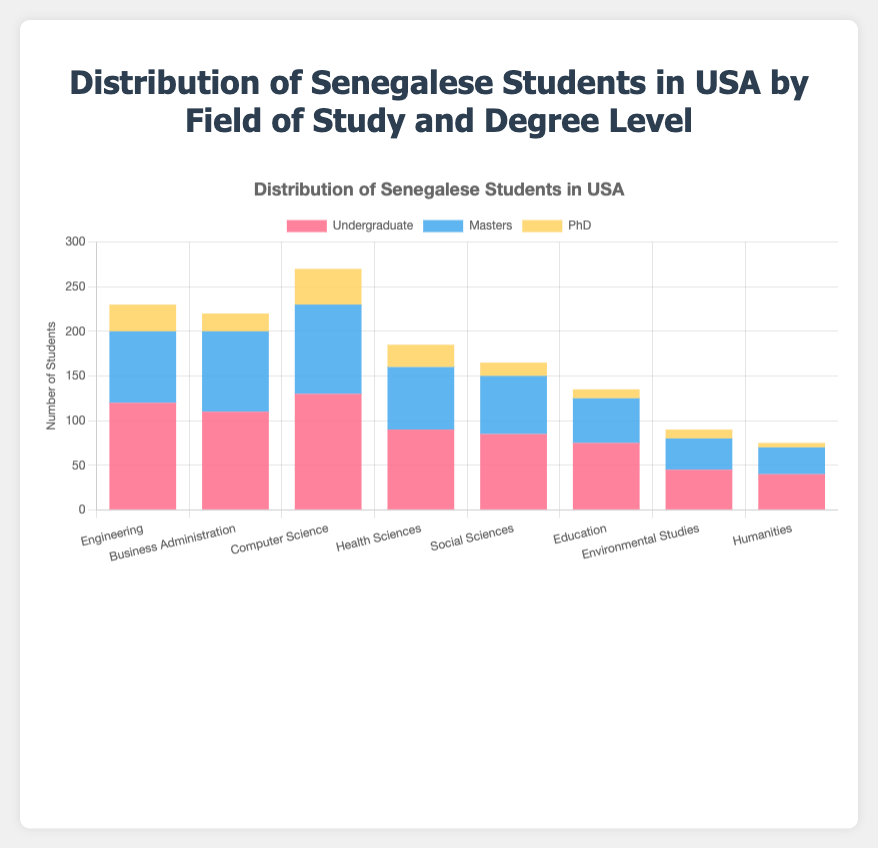What is the total number of Senegalese students studying Computer Science across all degree levels? To find the total number of students studying Computer Science, sum the numbers of Undergraduate (130), Masters (100), and PhD (40) students. The total is 130 + 100 + 40 = 270 students.
Answer: 270 Which field of study has the highest number of undergraduate students? By visually comparing the height of the bars for the undergraduate category, Computer Science has the highest bar at 130 students.
Answer: Computer Science How many more students are pursuing a Masters degree in Business Administration compared to PhD in Health Sciences? The number of Business Administration Masters students is 90. The number of Health Sciences PhD students is 25. The difference is 90 - 25 = 65 students.
Answer: 65 Are there more undergraduate students in Engineering than total students in Environmental Studies? The number of Undergraduate students in Engineering is 120. The total number of students in Environmental Studies is 45 + 35 + 10 = 90. Since 120 > 90, there are more undergraduate students in Engineering.
Answer: Yes What is the difference in the total number of Masters and PhD students in Business Administration? The number of Masters students in Business Administration is 90. The number of PhD students in Business Administration is 20. The difference is 90 - 20 = 70 students.
Answer: 70 How does the number of Computer Science Masters students compare to the number of Engineering Undergraduate students? The number of Computer Science Masters students is 100. The number of Engineering Undergraduate students is 120. Since 100 < 120, there are fewer Computer Science Masters students.
Answer: Fewer Which field of study has the most balanced distribution of students across all degree levels? A balanced distribution can be identified by comparing the heights of the bars within each category. Engineering (120, 80, 30) appears more balanced compared to other fields with wider discrepancies in student numbers across degree levels.
Answer: Engineering 